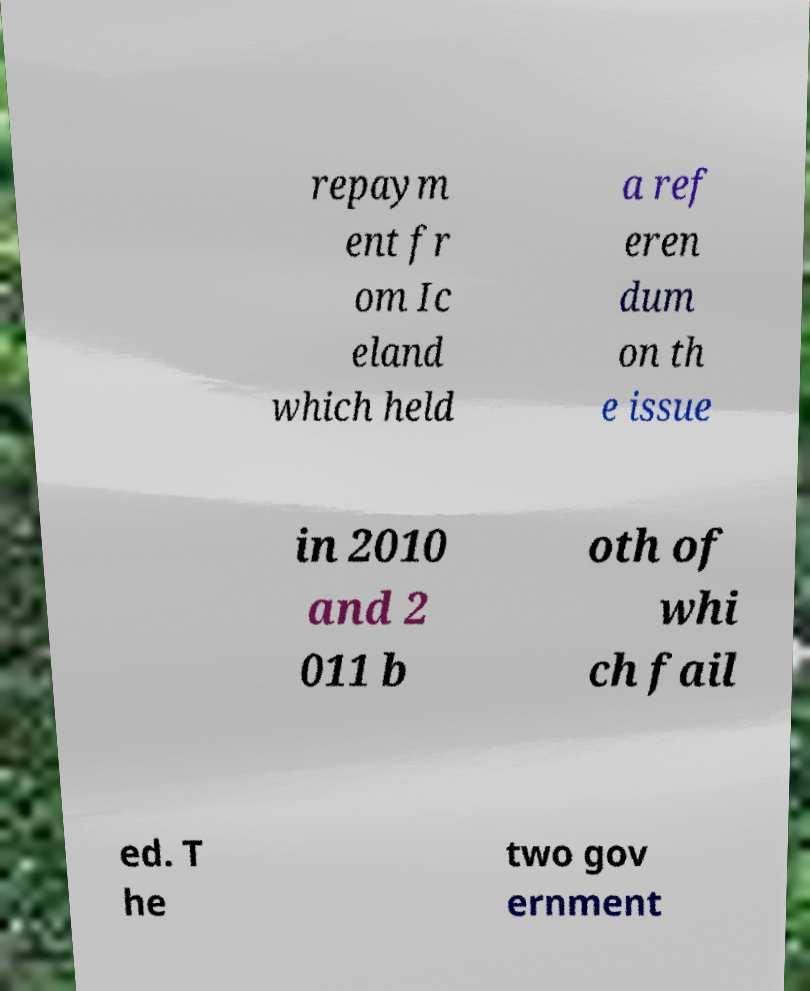Please identify and transcribe the text found in this image. repaym ent fr om Ic eland which held a ref eren dum on th e issue in 2010 and 2 011 b oth of whi ch fail ed. T he two gov ernment 